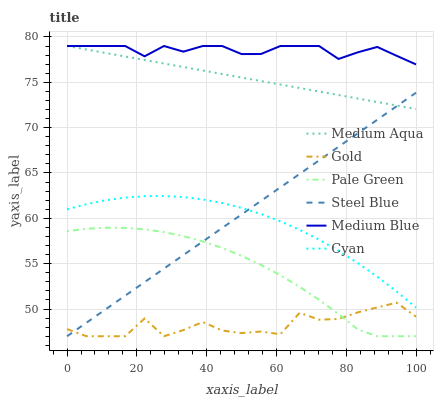Does Gold have the minimum area under the curve?
Answer yes or no. Yes. Does Medium Blue have the maximum area under the curve?
Answer yes or no. Yes. Does Steel Blue have the minimum area under the curve?
Answer yes or no. No. Does Steel Blue have the maximum area under the curve?
Answer yes or no. No. Is Medium Aqua the smoothest?
Answer yes or no. Yes. Is Gold the roughest?
Answer yes or no. Yes. Is Medium Blue the smoothest?
Answer yes or no. No. Is Medium Blue the roughest?
Answer yes or no. No. Does Gold have the lowest value?
Answer yes or no. Yes. Does Medium Blue have the lowest value?
Answer yes or no. No. Does Medium Aqua have the highest value?
Answer yes or no. Yes. Does Steel Blue have the highest value?
Answer yes or no. No. Is Gold less than Medium Blue?
Answer yes or no. Yes. Is Cyan greater than Pale Green?
Answer yes or no. Yes. Does Steel Blue intersect Medium Aqua?
Answer yes or no. Yes. Is Steel Blue less than Medium Aqua?
Answer yes or no. No. Is Steel Blue greater than Medium Aqua?
Answer yes or no. No. Does Gold intersect Medium Blue?
Answer yes or no. No. 